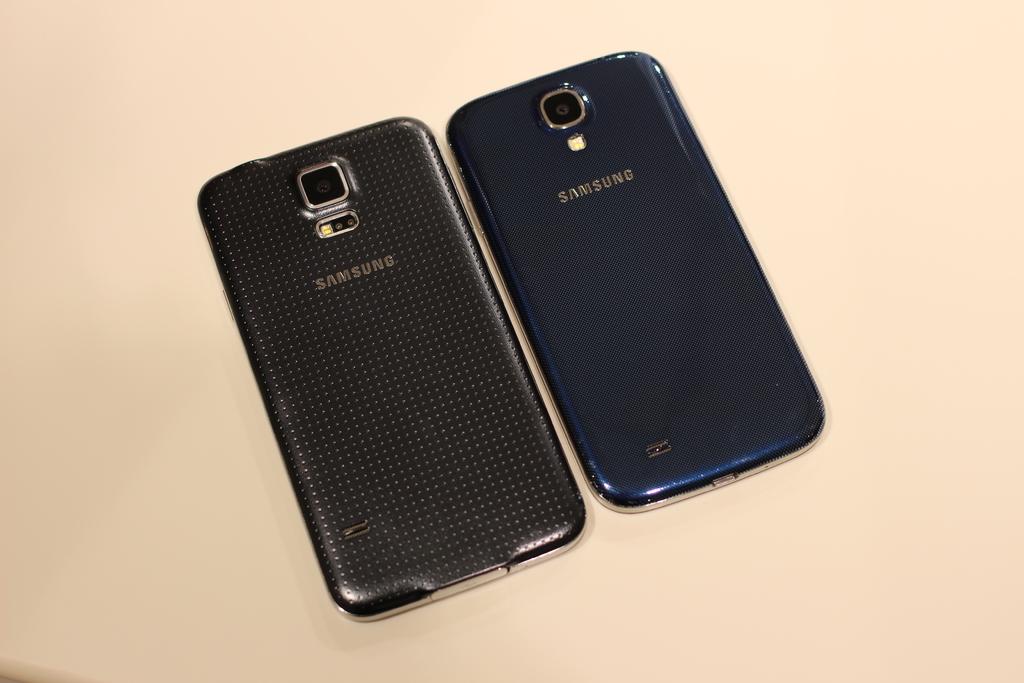Who is the manufacturer of these phones?
Keep it short and to the point. Samsung. Samsung is good company mobile?
Provide a succinct answer. Yes. 